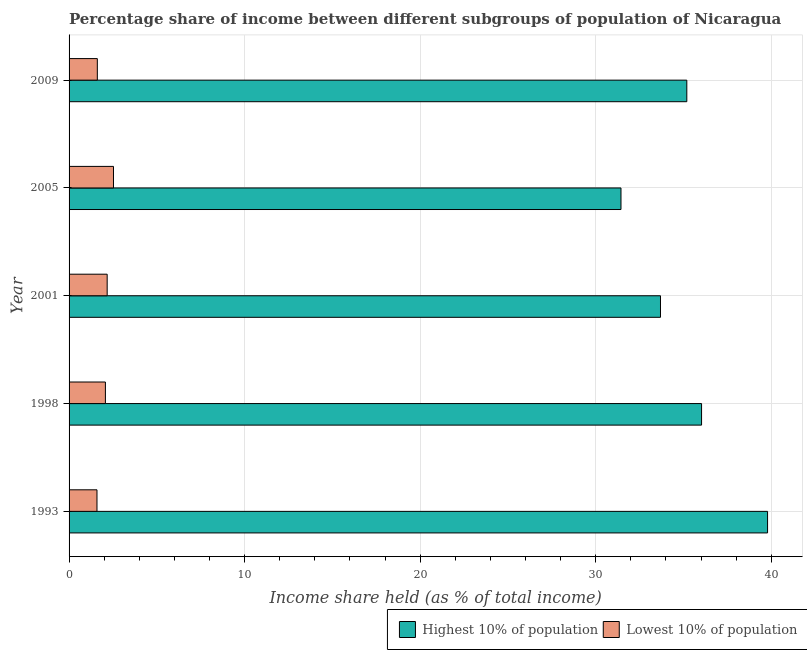How many different coloured bars are there?
Make the answer very short. 2. How many groups of bars are there?
Provide a succinct answer. 5. Are the number of bars per tick equal to the number of legend labels?
Offer a terse response. Yes. Are the number of bars on each tick of the Y-axis equal?
Keep it short and to the point. Yes. How many bars are there on the 5th tick from the top?
Offer a very short reply. 2. How many bars are there on the 3rd tick from the bottom?
Your response must be concise. 2. What is the income share held by highest 10% of the population in 2005?
Provide a succinct answer. 31.44. Across all years, what is the maximum income share held by highest 10% of the population?
Your answer should be very brief. 39.79. Across all years, what is the minimum income share held by lowest 10% of the population?
Your answer should be compact. 1.59. What is the total income share held by lowest 10% of the population in the graph?
Provide a succinct answer. 9.97. What is the difference between the income share held by highest 10% of the population in 2001 and that in 2005?
Provide a succinct answer. 2.25. What is the difference between the income share held by lowest 10% of the population in 2009 and the income share held by highest 10% of the population in 2005?
Provide a short and direct response. -29.83. What is the average income share held by highest 10% of the population per year?
Provide a succinct answer. 35.23. In the year 2009, what is the difference between the income share held by highest 10% of the population and income share held by lowest 10% of the population?
Provide a succinct answer. 33.58. In how many years, is the income share held by lowest 10% of the population greater than 16 %?
Your answer should be very brief. 0. What is the ratio of the income share held by highest 10% of the population in 2005 to that in 2009?
Offer a very short reply. 0.89. Is the difference between the income share held by lowest 10% of the population in 1993 and 2009 greater than the difference between the income share held by highest 10% of the population in 1993 and 2009?
Provide a succinct answer. No. What is the difference between the highest and the second highest income share held by lowest 10% of the population?
Give a very brief answer. 0.36. What is the difference between the highest and the lowest income share held by highest 10% of the population?
Provide a succinct answer. 8.35. What does the 2nd bar from the top in 2001 represents?
Your answer should be compact. Highest 10% of population. What does the 1st bar from the bottom in 2005 represents?
Give a very brief answer. Highest 10% of population. How many bars are there?
Make the answer very short. 10. Does the graph contain any zero values?
Your response must be concise. No. Does the graph contain grids?
Offer a terse response. Yes. Where does the legend appear in the graph?
Provide a succinct answer. Bottom right. How many legend labels are there?
Ensure brevity in your answer.  2. What is the title of the graph?
Provide a succinct answer. Percentage share of income between different subgroups of population of Nicaragua. What is the label or title of the X-axis?
Your answer should be compact. Income share held (as % of total income). What is the Income share held (as % of total income) in Highest 10% of population in 1993?
Make the answer very short. 39.79. What is the Income share held (as % of total income) in Lowest 10% of population in 1993?
Your answer should be very brief. 1.59. What is the Income share held (as % of total income) of Highest 10% of population in 1998?
Provide a succinct answer. 36.03. What is the Income share held (as % of total income) in Lowest 10% of population in 1998?
Ensure brevity in your answer.  2.07. What is the Income share held (as % of total income) of Highest 10% of population in 2001?
Your response must be concise. 33.69. What is the Income share held (as % of total income) in Lowest 10% of population in 2001?
Provide a succinct answer. 2.17. What is the Income share held (as % of total income) in Highest 10% of population in 2005?
Provide a short and direct response. 31.44. What is the Income share held (as % of total income) of Lowest 10% of population in 2005?
Ensure brevity in your answer.  2.53. What is the Income share held (as % of total income) in Highest 10% of population in 2009?
Offer a very short reply. 35.19. What is the Income share held (as % of total income) of Lowest 10% of population in 2009?
Your answer should be very brief. 1.61. Across all years, what is the maximum Income share held (as % of total income) in Highest 10% of population?
Offer a terse response. 39.79. Across all years, what is the maximum Income share held (as % of total income) of Lowest 10% of population?
Ensure brevity in your answer.  2.53. Across all years, what is the minimum Income share held (as % of total income) in Highest 10% of population?
Provide a succinct answer. 31.44. Across all years, what is the minimum Income share held (as % of total income) of Lowest 10% of population?
Offer a terse response. 1.59. What is the total Income share held (as % of total income) of Highest 10% of population in the graph?
Make the answer very short. 176.14. What is the total Income share held (as % of total income) in Lowest 10% of population in the graph?
Ensure brevity in your answer.  9.97. What is the difference between the Income share held (as % of total income) of Highest 10% of population in 1993 and that in 1998?
Your response must be concise. 3.76. What is the difference between the Income share held (as % of total income) of Lowest 10% of population in 1993 and that in 1998?
Your answer should be compact. -0.48. What is the difference between the Income share held (as % of total income) of Lowest 10% of population in 1993 and that in 2001?
Offer a very short reply. -0.58. What is the difference between the Income share held (as % of total income) of Highest 10% of population in 1993 and that in 2005?
Your answer should be compact. 8.35. What is the difference between the Income share held (as % of total income) in Lowest 10% of population in 1993 and that in 2005?
Your answer should be very brief. -0.94. What is the difference between the Income share held (as % of total income) of Lowest 10% of population in 1993 and that in 2009?
Give a very brief answer. -0.02. What is the difference between the Income share held (as % of total income) of Highest 10% of population in 1998 and that in 2001?
Offer a terse response. 2.34. What is the difference between the Income share held (as % of total income) of Highest 10% of population in 1998 and that in 2005?
Provide a short and direct response. 4.59. What is the difference between the Income share held (as % of total income) in Lowest 10% of population in 1998 and that in 2005?
Provide a succinct answer. -0.46. What is the difference between the Income share held (as % of total income) of Highest 10% of population in 1998 and that in 2009?
Your answer should be compact. 0.84. What is the difference between the Income share held (as % of total income) in Lowest 10% of population in 1998 and that in 2009?
Your answer should be very brief. 0.46. What is the difference between the Income share held (as % of total income) of Highest 10% of population in 2001 and that in 2005?
Your answer should be compact. 2.25. What is the difference between the Income share held (as % of total income) in Lowest 10% of population in 2001 and that in 2005?
Your response must be concise. -0.36. What is the difference between the Income share held (as % of total income) of Lowest 10% of population in 2001 and that in 2009?
Make the answer very short. 0.56. What is the difference between the Income share held (as % of total income) in Highest 10% of population in 2005 and that in 2009?
Provide a short and direct response. -3.75. What is the difference between the Income share held (as % of total income) of Highest 10% of population in 1993 and the Income share held (as % of total income) of Lowest 10% of population in 1998?
Your answer should be compact. 37.72. What is the difference between the Income share held (as % of total income) in Highest 10% of population in 1993 and the Income share held (as % of total income) in Lowest 10% of population in 2001?
Your answer should be very brief. 37.62. What is the difference between the Income share held (as % of total income) in Highest 10% of population in 1993 and the Income share held (as % of total income) in Lowest 10% of population in 2005?
Your answer should be very brief. 37.26. What is the difference between the Income share held (as % of total income) in Highest 10% of population in 1993 and the Income share held (as % of total income) in Lowest 10% of population in 2009?
Your response must be concise. 38.18. What is the difference between the Income share held (as % of total income) of Highest 10% of population in 1998 and the Income share held (as % of total income) of Lowest 10% of population in 2001?
Give a very brief answer. 33.86. What is the difference between the Income share held (as % of total income) of Highest 10% of population in 1998 and the Income share held (as % of total income) of Lowest 10% of population in 2005?
Keep it short and to the point. 33.5. What is the difference between the Income share held (as % of total income) in Highest 10% of population in 1998 and the Income share held (as % of total income) in Lowest 10% of population in 2009?
Give a very brief answer. 34.42. What is the difference between the Income share held (as % of total income) in Highest 10% of population in 2001 and the Income share held (as % of total income) in Lowest 10% of population in 2005?
Keep it short and to the point. 31.16. What is the difference between the Income share held (as % of total income) of Highest 10% of population in 2001 and the Income share held (as % of total income) of Lowest 10% of population in 2009?
Your response must be concise. 32.08. What is the difference between the Income share held (as % of total income) of Highest 10% of population in 2005 and the Income share held (as % of total income) of Lowest 10% of population in 2009?
Give a very brief answer. 29.83. What is the average Income share held (as % of total income) of Highest 10% of population per year?
Your answer should be compact. 35.23. What is the average Income share held (as % of total income) of Lowest 10% of population per year?
Offer a terse response. 1.99. In the year 1993, what is the difference between the Income share held (as % of total income) of Highest 10% of population and Income share held (as % of total income) of Lowest 10% of population?
Keep it short and to the point. 38.2. In the year 1998, what is the difference between the Income share held (as % of total income) in Highest 10% of population and Income share held (as % of total income) in Lowest 10% of population?
Offer a very short reply. 33.96. In the year 2001, what is the difference between the Income share held (as % of total income) of Highest 10% of population and Income share held (as % of total income) of Lowest 10% of population?
Give a very brief answer. 31.52. In the year 2005, what is the difference between the Income share held (as % of total income) in Highest 10% of population and Income share held (as % of total income) in Lowest 10% of population?
Keep it short and to the point. 28.91. In the year 2009, what is the difference between the Income share held (as % of total income) of Highest 10% of population and Income share held (as % of total income) of Lowest 10% of population?
Offer a very short reply. 33.58. What is the ratio of the Income share held (as % of total income) of Highest 10% of population in 1993 to that in 1998?
Give a very brief answer. 1.1. What is the ratio of the Income share held (as % of total income) of Lowest 10% of population in 1993 to that in 1998?
Offer a terse response. 0.77. What is the ratio of the Income share held (as % of total income) of Highest 10% of population in 1993 to that in 2001?
Make the answer very short. 1.18. What is the ratio of the Income share held (as % of total income) in Lowest 10% of population in 1993 to that in 2001?
Make the answer very short. 0.73. What is the ratio of the Income share held (as % of total income) in Highest 10% of population in 1993 to that in 2005?
Keep it short and to the point. 1.27. What is the ratio of the Income share held (as % of total income) in Lowest 10% of population in 1993 to that in 2005?
Ensure brevity in your answer.  0.63. What is the ratio of the Income share held (as % of total income) of Highest 10% of population in 1993 to that in 2009?
Offer a terse response. 1.13. What is the ratio of the Income share held (as % of total income) in Lowest 10% of population in 1993 to that in 2009?
Offer a very short reply. 0.99. What is the ratio of the Income share held (as % of total income) of Highest 10% of population in 1998 to that in 2001?
Ensure brevity in your answer.  1.07. What is the ratio of the Income share held (as % of total income) in Lowest 10% of population in 1998 to that in 2001?
Provide a short and direct response. 0.95. What is the ratio of the Income share held (as % of total income) of Highest 10% of population in 1998 to that in 2005?
Give a very brief answer. 1.15. What is the ratio of the Income share held (as % of total income) of Lowest 10% of population in 1998 to that in 2005?
Provide a succinct answer. 0.82. What is the ratio of the Income share held (as % of total income) in Highest 10% of population in 1998 to that in 2009?
Keep it short and to the point. 1.02. What is the ratio of the Income share held (as % of total income) in Highest 10% of population in 2001 to that in 2005?
Your response must be concise. 1.07. What is the ratio of the Income share held (as % of total income) in Lowest 10% of population in 2001 to that in 2005?
Your answer should be very brief. 0.86. What is the ratio of the Income share held (as % of total income) of Highest 10% of population in 2001 to that in 2009?
Offer a very short reply. 0.96. What is the ratio of the Income share held (as % of total income) in Lowest 10% of population in 2001 to that in 2009?
Your response must be concise. 1.35. What is the ratio of the Income share held (as % of total income) in Highest 10% of population in 2005 to that in 2009?
Provide a succinct answer. 0.89. What is the ratio of the Income share held (as % of total income) in Lowest 10% of population in 2005 to that in 2009?
Provide a succinct answer. 1.57. What is the difference between the highest and the second highest Income share held (as % of total income) of Highest 10% of population?
Ensure brevity in your answer.  3.76. What is the difference between the highest and the second highest Income share held (as % of total income) in Lowest 10% of population?
Make the answer very short. 0.36. What is the difference between the highest and the lowest Income share held (as % of total income) of Highest 10% of population?
Your answer should be compact. 8.35. 